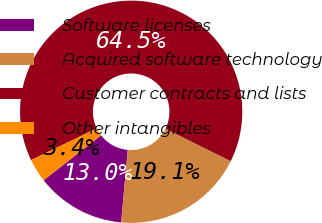Convert chart to OTSL. <chart><loc_0><loc_0><loc_500><loc_500><pie_chart><fcel>Software licenses<fcel>Acquired software technology<fcel>Customer contracts and lists<fcel>Other intangibles<nl><fcel>13.0%<fcel>19.11%<fcel>64.48%<fcel>3.4%<nl></chart> 